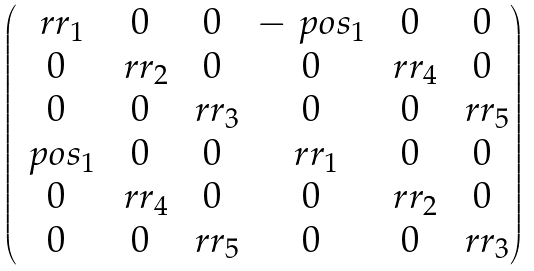Convert formula to latex. <formula><loc_0><loc_0><loc_500><loc_500>\begin{pmatrix} \ r r _ { 1 } & 0 & 0 & - \ p o s _ { 1 } & 0 & 0 \\ 0 & \ r r _ { 2 } & 0 & 0 & \ r r _ { 4 } & 0 \\ 0 & 0 & \ r r _ { 3 } & 0 & 0 & \ r r _ { 5 } \\ \ p o s _ { 1 } & 0 & 0 & \ r r _ { 1 } & 0 & 0 \\ 0 & \ r r _ { 4 } & 0 & 0 & \ r r _ { 2 } & 0 \\ 0 & 0 & \ r r _ { 5 } & 0 & 0 & \ r r _ { 3 } \end{pmatrix}</formula> 